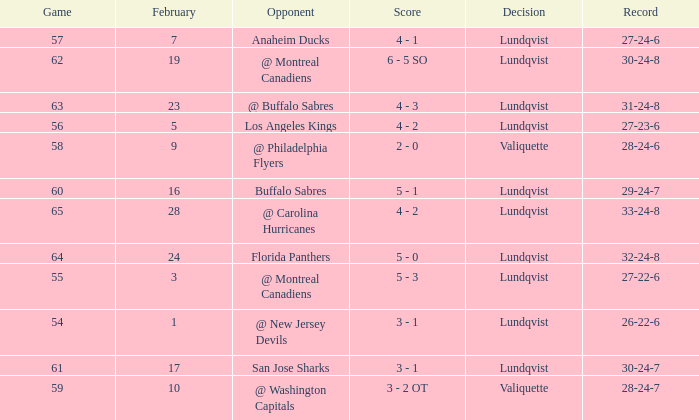What's the score for a game over 56 with a record of 29-24-7 with a lundqvist decision? 5 - 1. 